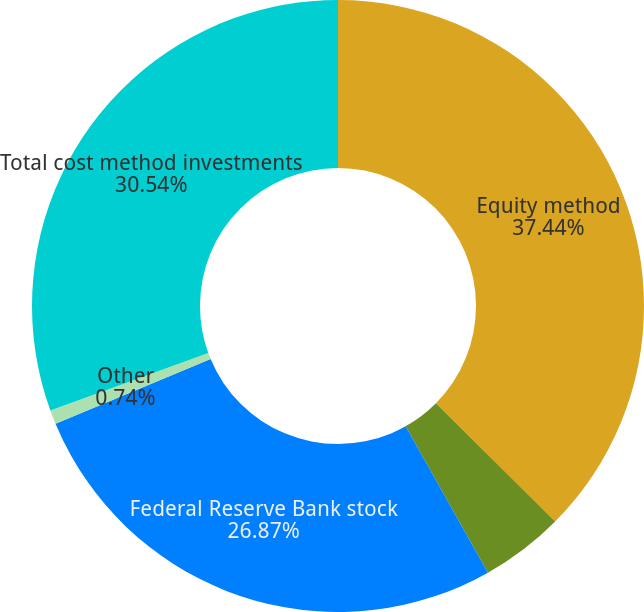Convert chart to OTSL. <chart><loc_0><loc_0><loc_500><loc_500><pie_chart><fcel>Equity method<fcel>Deferred compensation plan<fcel>Federal Reserve Bank stock<fcel>Other<fcel>Total cost method investments<nl><fcel>37.44%<fcel>4.41%<fcel>26.87%<fcel>0.74%<fcel>30.54%<nl></chart> 